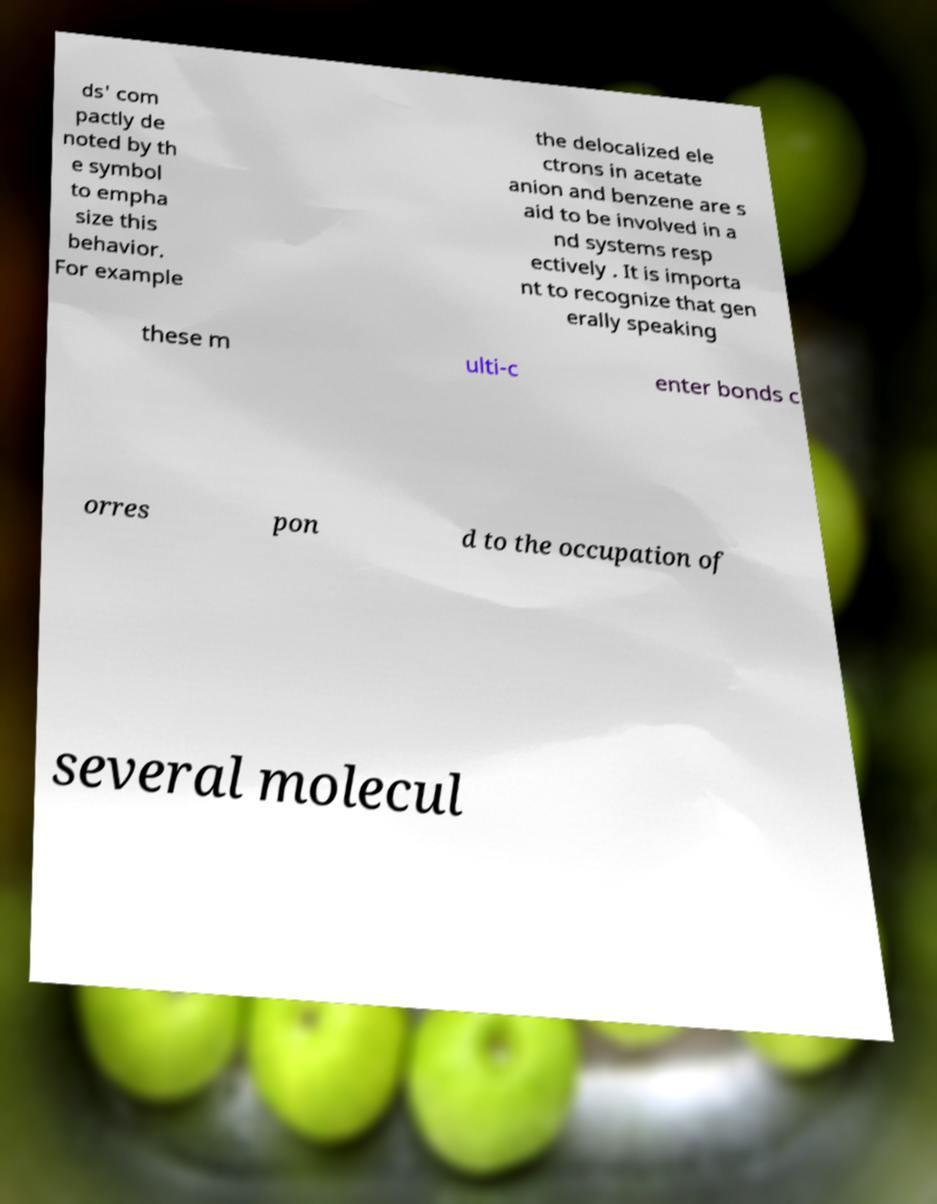Could you assist in decoding the text presented in this image and type it out clearly? ds' com pactly de noted by th e symbol to empha size this behavior. For example the delocalized ele ctrons in acetate anion and benzene are s aid to be involved in a nd systems resp ectively . It is importa nt to recognize that gen erally speaking these m ulti-c enter bonds c orres pon d to the occupation of several molecul 